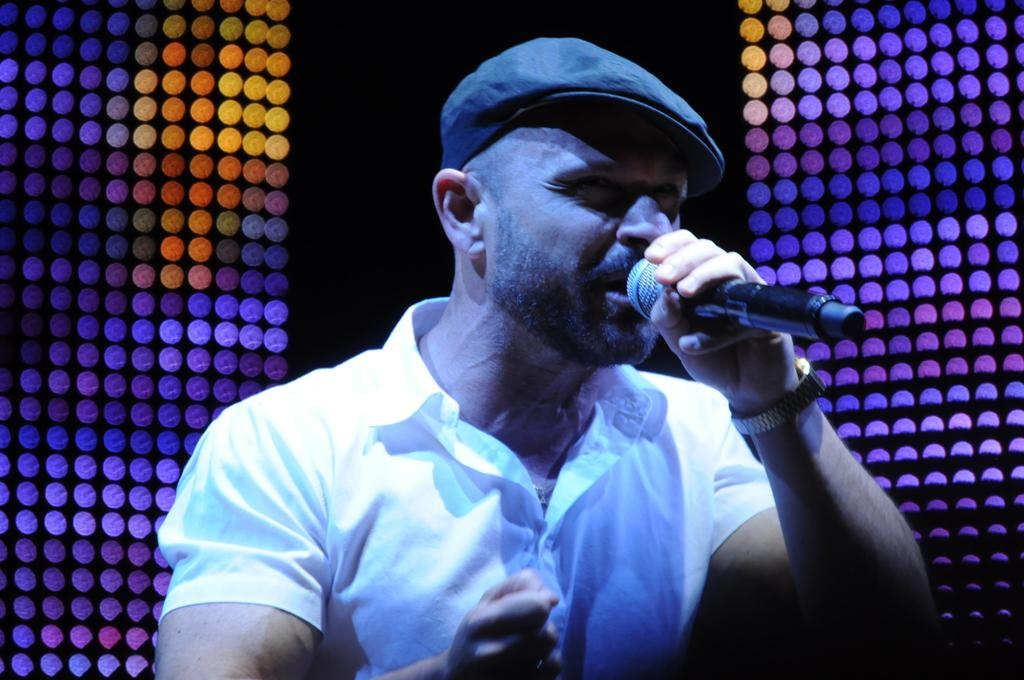What is the man in the image holding? The man is holding a mic in the image. What can be seen in the background of the image? There are spotlights in the background of the image. What type of dress is the man wearing in the image? The man is not wearing a dress in the image; he is wearing clothes appropriate for holding a mic. 